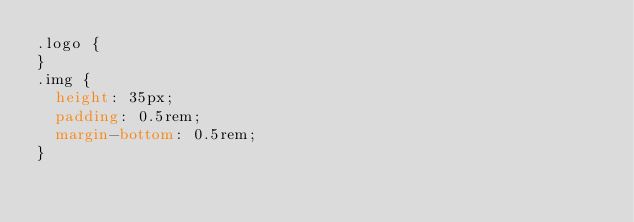Convert code to text. <code><loc_0><loc_0><loc_500><loc_500><_CSS_>.logo {
}
.img {
  height: 35px;
  padding: 0.5rem;
  margin-bottom: 0.5rem;
}
</code> 